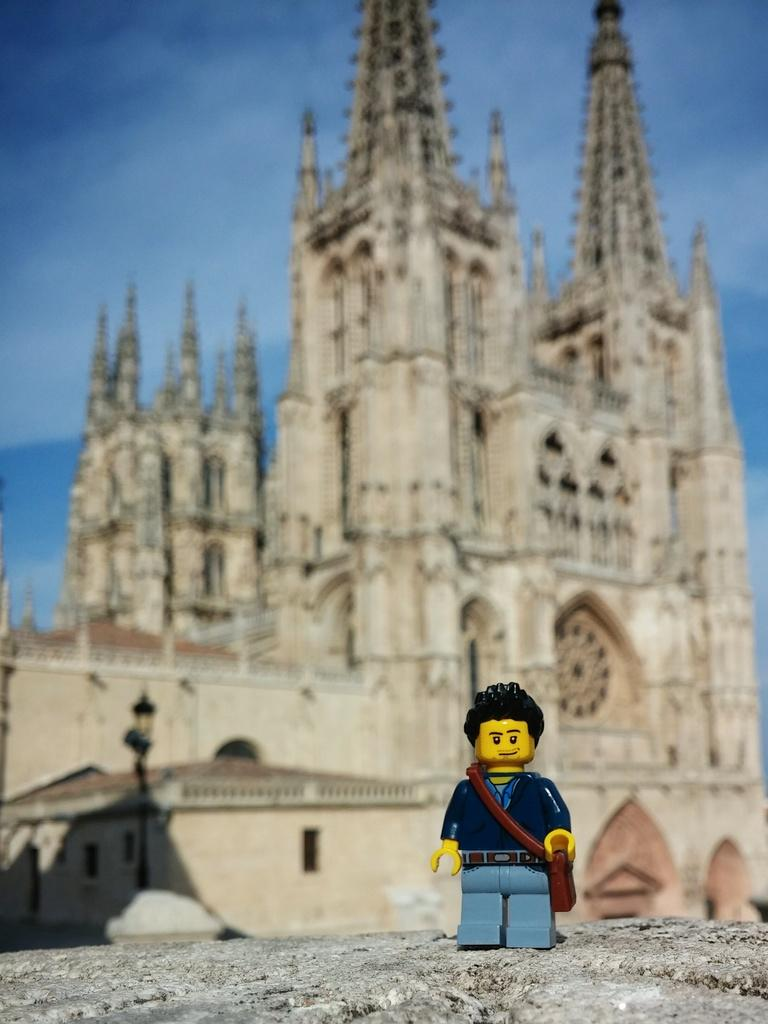What is the main subject of the image? There is a depiction of a boy in the image. What can be seen in the background of the image? There is a church in the background of the image. What is located in front of the church in the image? There is a street light in front of the church. What is visible in the sky in the image? The sky is visible in the background of the image. Can you tell me how many dinosaurs are walking down the street in the image? There are no dinosaurs present in the image; it features a boy, a church, a street light, and the sky. What type of town is depicted in the image? The image does not depict a town; it focuses on the boy, the church, the street light, and the sky. 